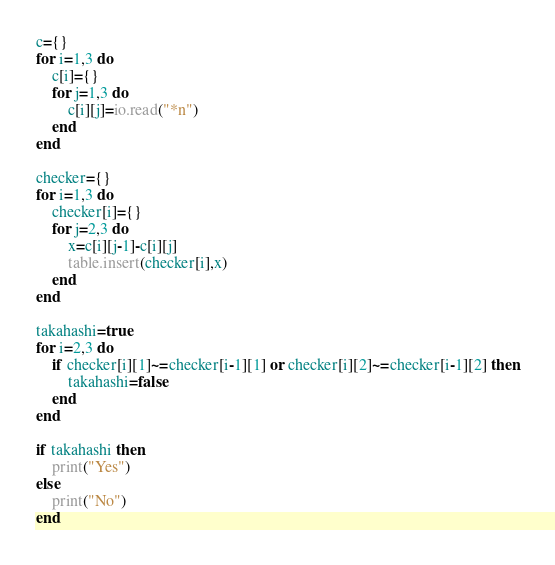<code> <loc_0><loc_0><loc_500><loc_500><_Lua_>c={}
for i=1,3 do
    c[i]={}
    for j=1,3 do
        c[i][j]=io.read("*n")
    end
end

checker={}
for i=1,3 do
    checker[i]={}
    for j=2,3 do
        x=c[i][j-1]-c[i][j]
        table.insert(checker[i],x)
    end
end

takahashi=true
for i=2,3 do
    if checker[i][1]~=checker[i-1][1] or checker[i][2]~=checker[i-1][2] then
        takahashi=false
    end
end

if takahashi then
    print("Yes")
else
    print("No")
end</code> 